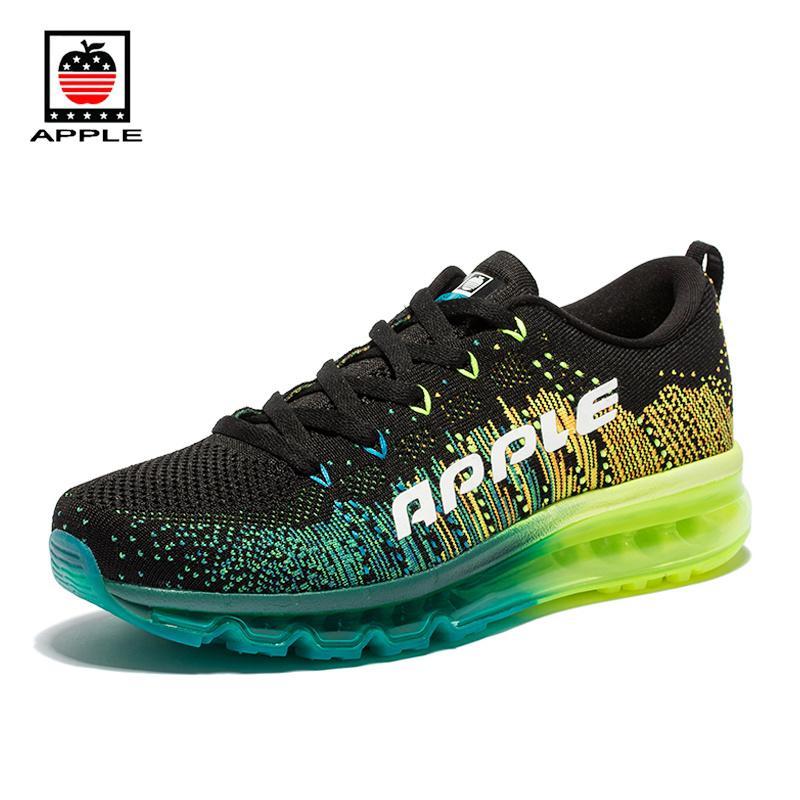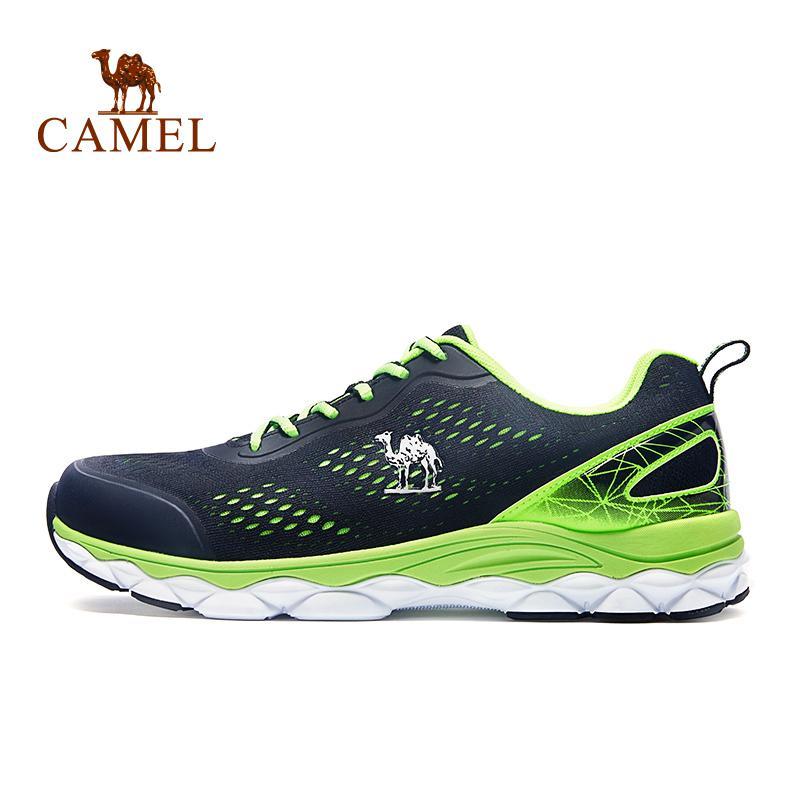The first image is the image on the left, the second image is the image on the right. Considering the images on both sides, is "All shoes are laced with black shoestrings." valid? Answer yes or no. No. The first image is the image on the left, the second image is the image on the right. For the images displayed, is the sentence "One shoe has a blue heel." factually correct? Answer yes or no. No. 